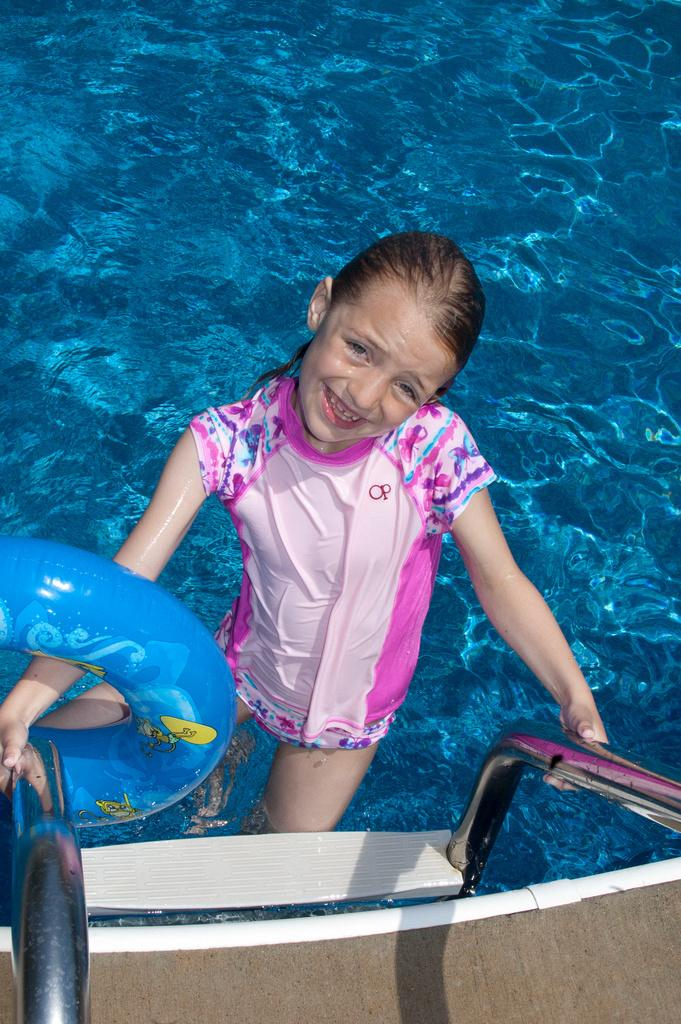Who is present in the image? There is a girl in the image. What is the girl doing in the image? The girl is smiling in the image. Where is the girl located in the image? The girl is in a swimming pool in the image. What safety item can be seen in the image? There is a safety ring in the image. What type of swing is the girl using in the image? There is no swing present in the image; the girl is in a swimming pool. 